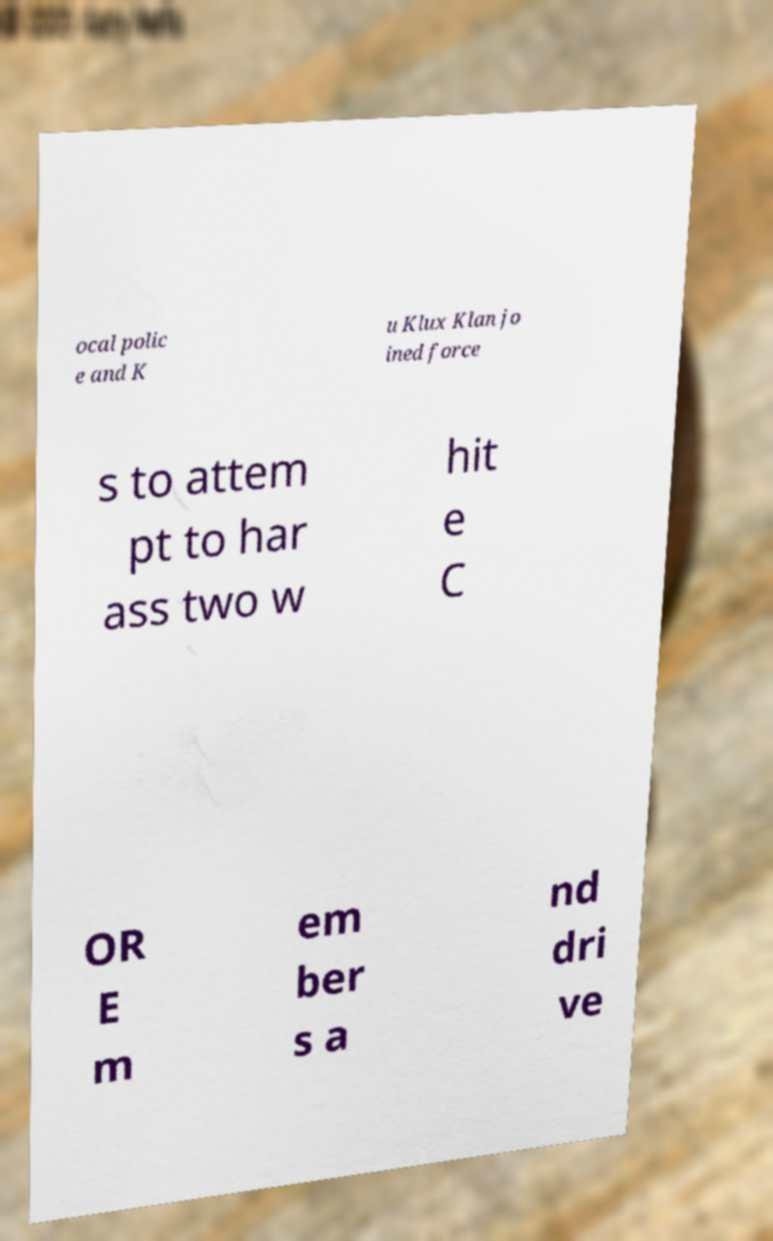What messages or text are displayed in this image? I need them in a readable, typed format. ocal polic e and K u Klux Klan jo ined force s to attem pt to har ass two w hit e C OR E m em ber s a nd dri ve 